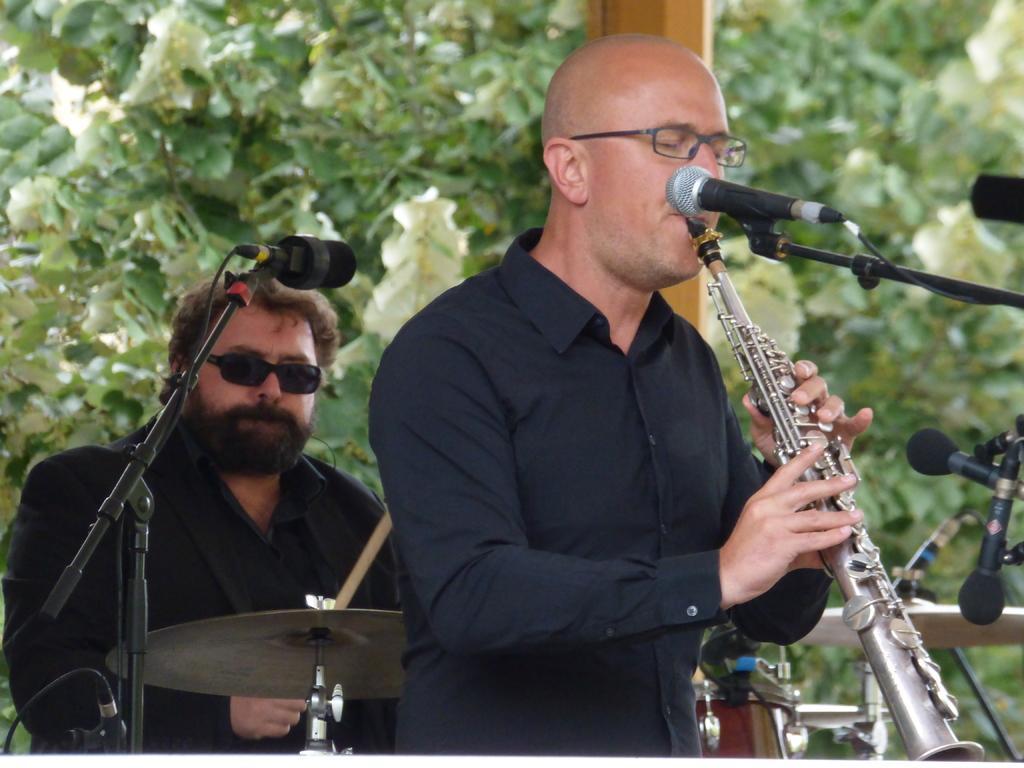Can you describe this image briefly? In the image I can see two people who are playing some musical instruments in front of the mic. 